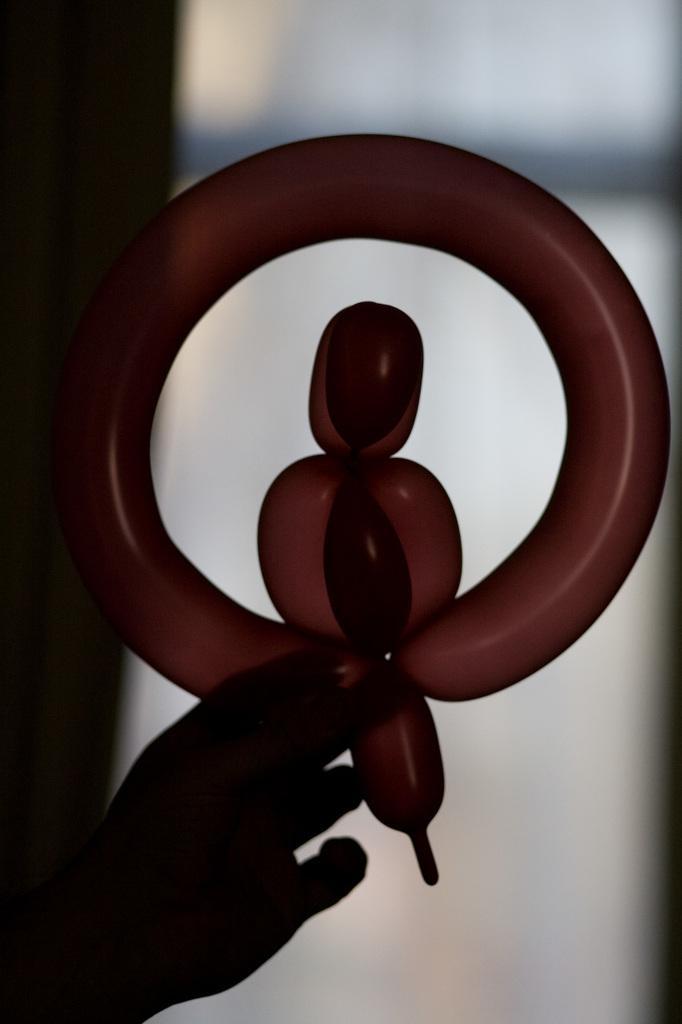How would you summarize this image in a sentence or two? In this image we can see there is a person's hand holding a balloon which in a shape. And at the back it looks like a blur. 